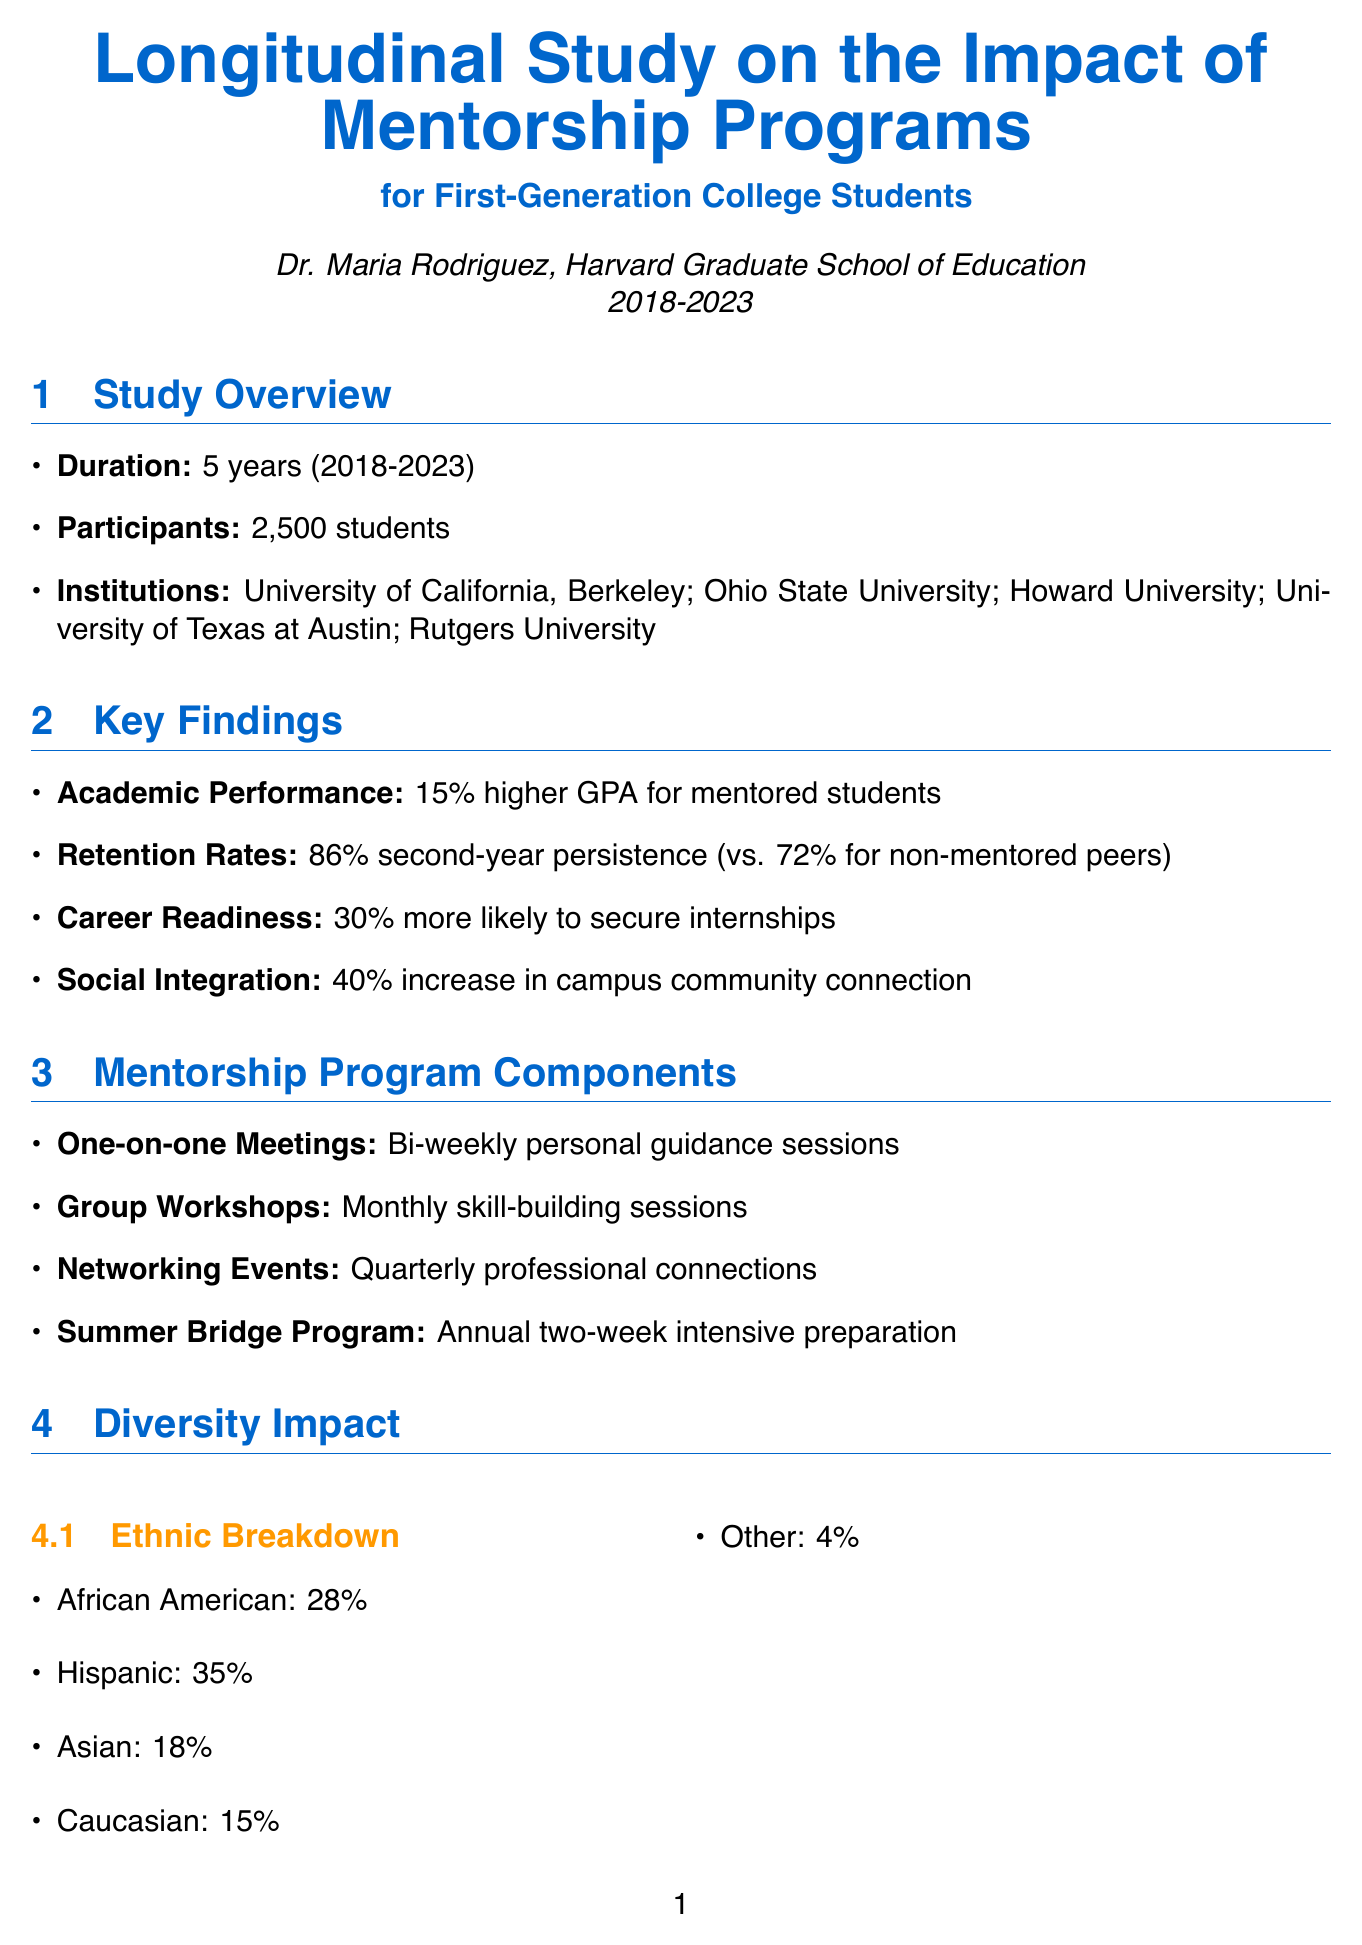What is the title of the study? The title of the study is provided in the document, which is specified at the beginning of the report.
Answer: Longitudinal Study on the Impact of Mentorship Programs for First-Generation College Students Who is the lead researcher? The lead researcher is mentioned directly following the title of the study, identifying the individual responsible for the research.
Answer: Dr. Maria Rodriguez How many participants were involved in the study? The total number of participants is stated in the Study Overview section.
Answer: 2500 What was the percentage increase in GPA for mentored students? This result is found in the Key Findings section, where academic performance is highlighted.
Answer: 15% What percentage of mentored students persisted to their second year? The retention rate is specifically noted in the Key Findings section of the document, comparing mentored to non-mentored students.
Answer: 86% What is one component of the mentorship program? The document lists several components of the program, and any of them can be an answer.
Answer: One-on-one Meetings What is the percentage of first-generation students from low-income backgrounds? This statistic is found in the Diversity Impact section, detailing socioeconomic backgrounds of the participants.
Answer: 62% Which organization provided a financial grant? The Supporting Organizations section details contributions from various organizations, including their contribution types.
Answer: Gates Foundation What is one recommendation for scaling mentorship programs? Recommendations for improving and expanding mentorship programs are specifically listed in the Recommendations for Scaling section.
Answer: Implement a national mentorship database 